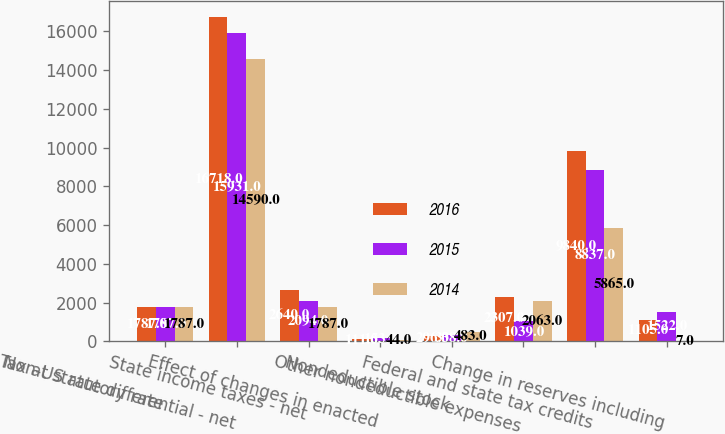Convert chart. <chart><loc_0><loc_0><loc_500><loc_500><stacked_bar_chart><ecel><fcel>Tax at statutory rate<fcel>Non-US rate differential - net<fcel>State income taxes - net<fcel>Effect of changes in enacted<fcel>Nondeductible stock<fcel>Other nondeductible expenses<fcel>Federal and state tax credits<fcel>Change in reserves including<nl><fcel>2016<fcel>1787<fcel>16718<fcel>2640<fcel>111<fcel>296<fcel>2307<fcel>9840<fcel>1105<nl><fcel>2015<fcel>1787<fcel>15931<fcel>2094<fcel>153<fcel>338<fcel>1039<fcel>8837<fcel>1522<nl><fcel>2014<fcel>1787<fcel>14590<fcel>1787<fcel>44<fcel>483<fcel>2063<fcel>5865<fcel>7<nl></chart> 